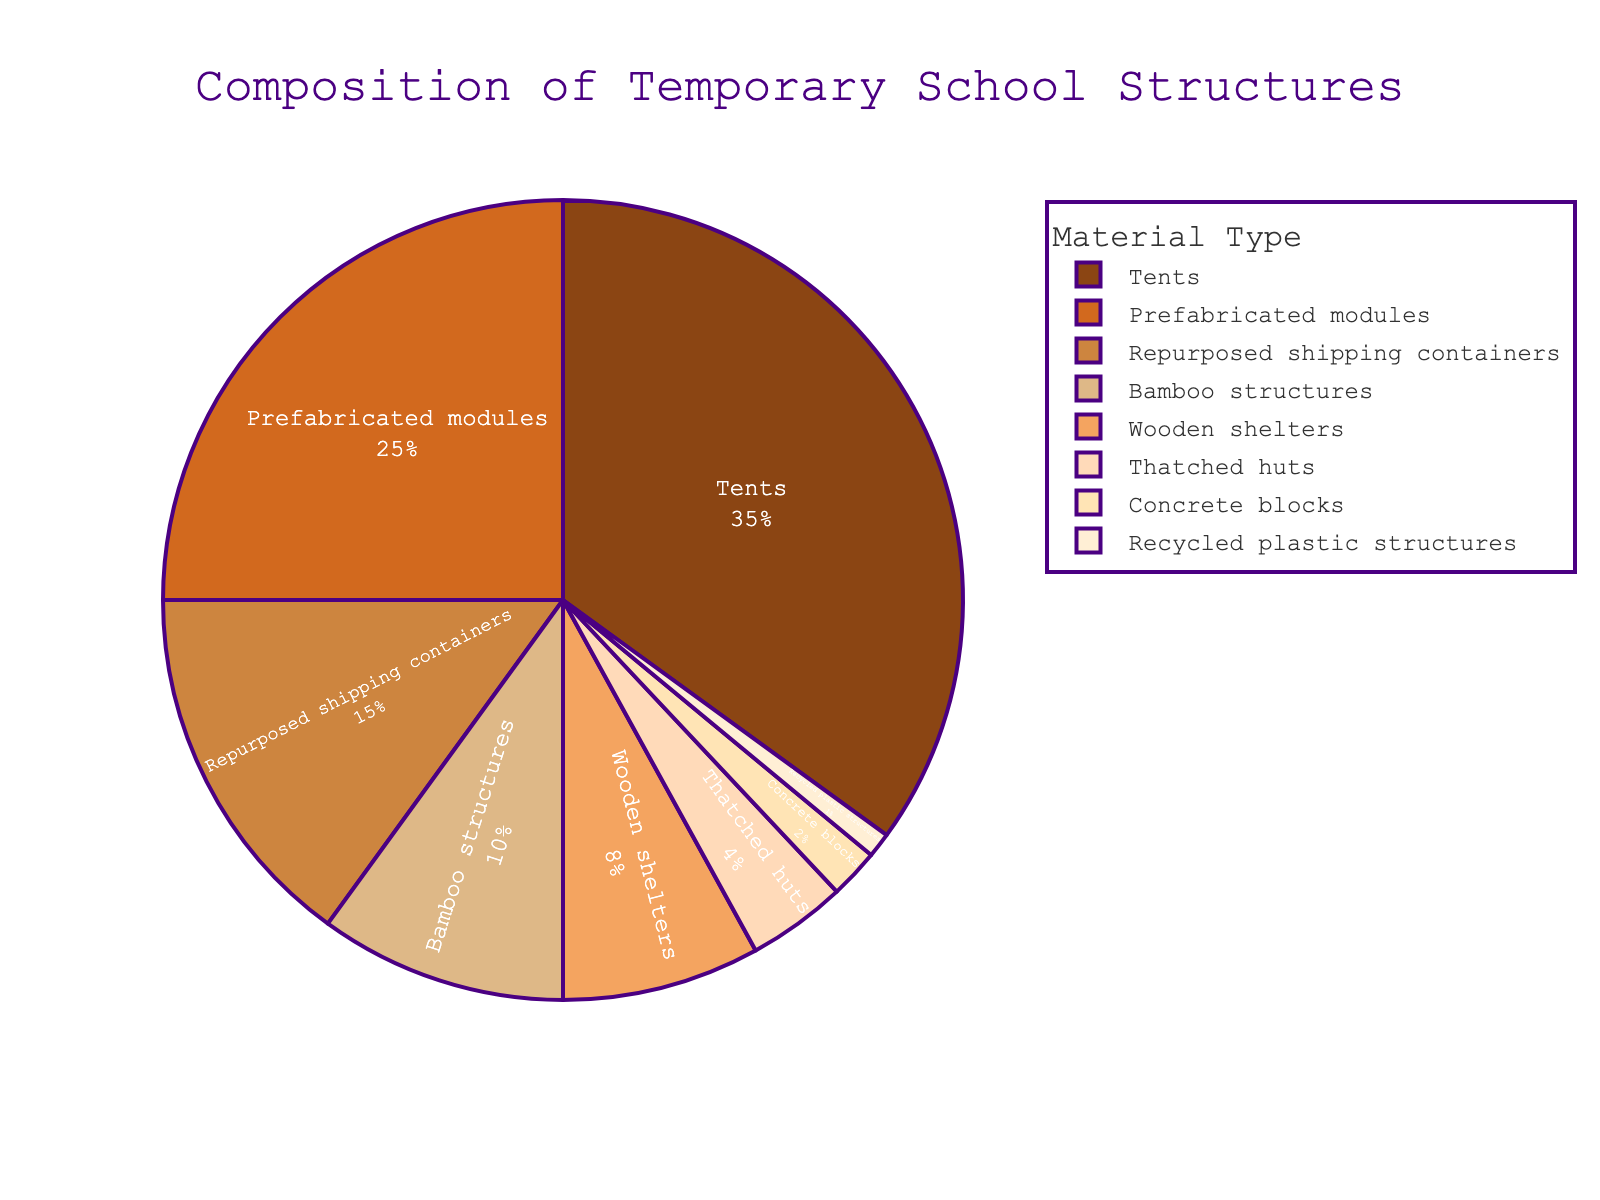Which material type occupies the largest portion of the school structures? By visual inspection, the largest portion in the pie chart is assigned to 'Tents'.
Answer: Tents What is the combined percentage of Prefabricated modules and Repurposed shipping containers? Adding the percentages of Prefabricated modules (25) and Repurposed shipping containers (15) gives 40%.
Answer: 40% How many materials make up less than 10% each? By identifying the percentages less than 10%: Bamboo structures (10), Wooden shelters (8), Thatched huts (4), Concrete blocks (2), Recycled plastic structures (1). There are 5 materials.
Answer: 5 What percentage do the three smallest material types contribute together? Adding the percentages of Thatched huts (4), Concrete blocks (2), and Recycled plastic structures (1) gives 7%.
Answer: 7% Which material type is closest in percentage to Wooden shelters? Bamboo structures are 10% and Wooden shelters are 8%, making Bamboo structures the closest by difference.
Answer: Bamboo structures Are the combined percentages of wooden and bamboo structures greater than prefabricated modules? Yes, Wooden shelters (8%) + Bamboo structures (10%) = 18%, which is less than Prefabricated modules (25%).
Answer: No Are tents more than twice as common as prefabricated modules? Tents have 35%, and twice Prefabricated modules would be 50% (2*25). Since 35% is less than 50%, Tents are not more than twice as common.
Answer: No What is the difference in percentage between the most used and the least used material type? Tents are 35% and Recycled plastic structures are 1%. The difference would be 35% - 1% = 34%.
Answer: 34% Which material type has a percentage almost equal to the sum of Concrete blocks and Bamboo structures? Adding Concrete blocks (2%) and Bamboo structures (10%) gives 12%. By looking at the pie chart, Wooden shelters with 8% is closest to this sum.
Answer: Wooden shelters Which materials together make up exactly 50% of the total? Adding Tents (35%) and Prefabricated modules (25%) gives a total of 60%, which is more than 50%. Thus, the exact combination of 50% with other subsets gives: Bamboo structures (10%), Wooden shelters (8%), Thatched huts (4%), Concrete blocks (2%), Recycled plastic structures (1%) = 25%. Adding Repurposed shipping containers (15%) = 40%. Lastly, adding Prefabricated modules (25%) = 65%. Closest but does not sum up correctly to exactly 50%.
Answer: None 